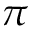<formula> <loc_0><loc_0><loc_500><loc_500>\pi</formula> 